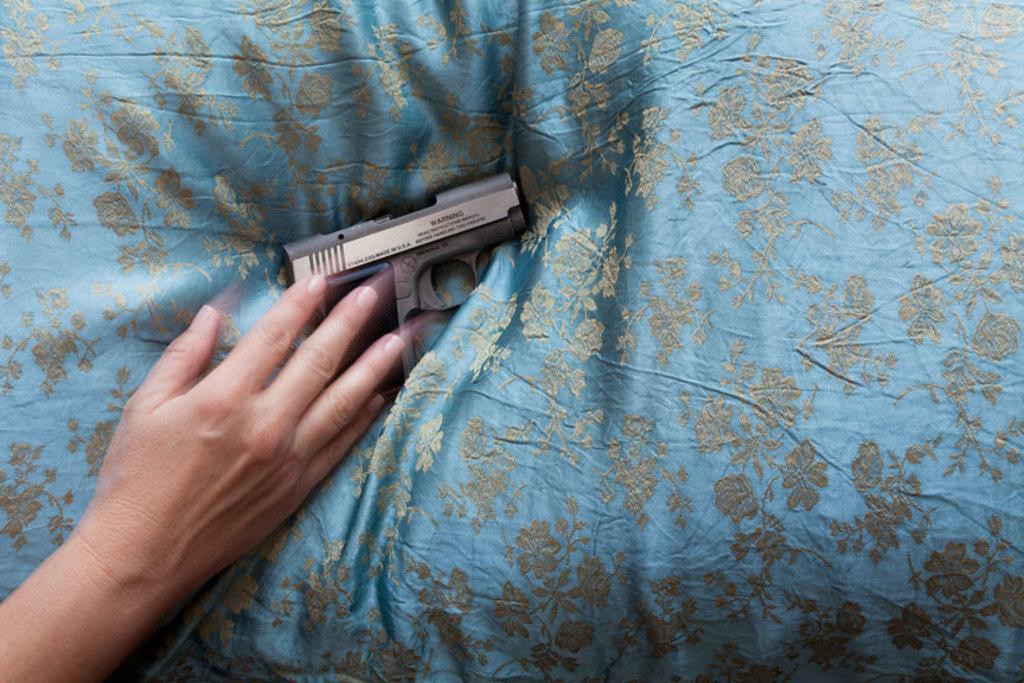Please provide a concise description of this image. In this picture I can see the person's hand who is kept on the pillow. In that pillow I can see the gun. 